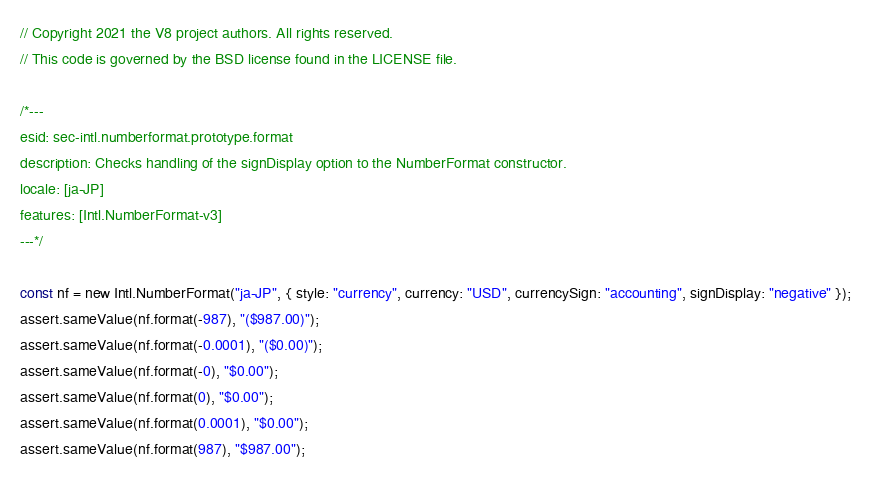Convert code to text. <code><loc_0><loc_0><loc_500><loc_500><_JavaScript_>// Copyright 2021 the V8 project authors. All rights reserved.
// This code is governed by the BSD license found in the LICENSE file.

/*---
esid: sec-intl.numberformat.prototype.format
description: Checks handling of the signDisplay option to the NumberFormat constructor.
locale: [ja-JP]
features: [Intl.NumberFormat-v3]
---*/

const nf = new Intl.NumberFormat("ja-JP", { style: "currency", currency: "USD", currencySign: "accounting", signDisplay: "negative" });
assert.sameValue(nf.format(-987), "($987.00)");
assert.sameValue(nf.format(-0.0001), "($0.00)");
assert.sameValue(nf.format(-0), "$0.00");
assert.sameValue(nf.format(0), "$0.00");
assert.sameValue(nf.format(0.0001), "$0.00");
assert.sameValue(nf.format(987), "$987.00");
</code> 